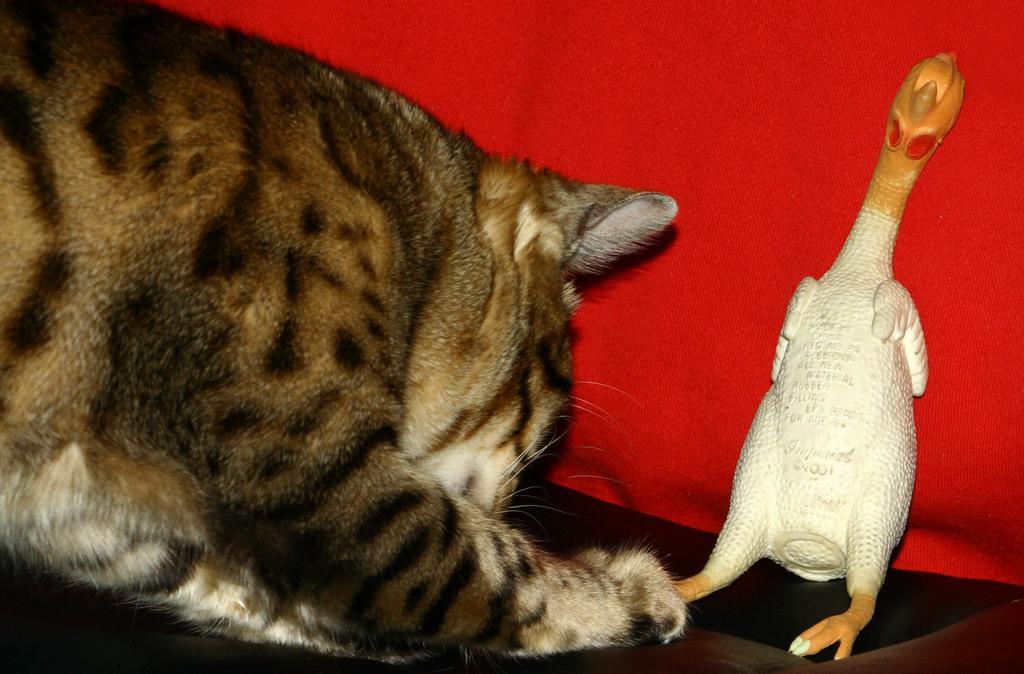In one or two sentences, can you explain what this image depicts? On the left side, there is a cat. On the right side, there is a doll. In the background, there is a red color sheet. 